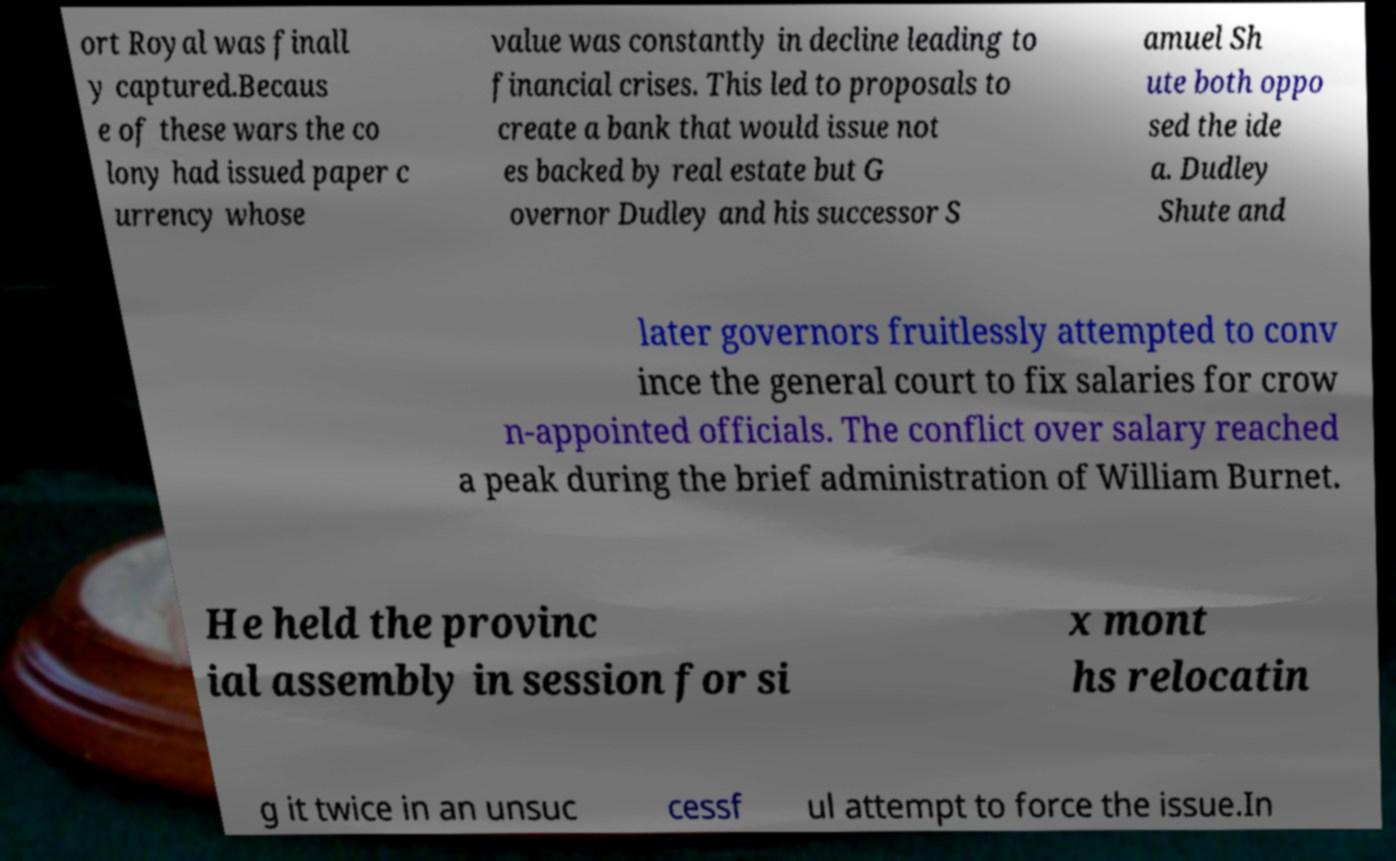There's text embedded in this image that I need extracted. Can you transcribe it verbatim? ort Royal was finall y captured.Becaus e of these wars the co lony had issued paper c urrency whose value was constantly in decline leading to financial crises. This led to proposals to create a bank that would issue not es backed by real estate but G overnor Dudley and his successor S amuel Sh ute both oppo sed the ide a. Dudley Shute and later governors fruitlessly attempted to conv ince the general court to fix salaries for crow n-appointed officials. The conflict over salary reached a peak during the brief administration of William Burnet. He held the provinc ial assembly in session for si x mont hs relocatin g it twice in an unsuc cessf ul attempt to force the issue.In 